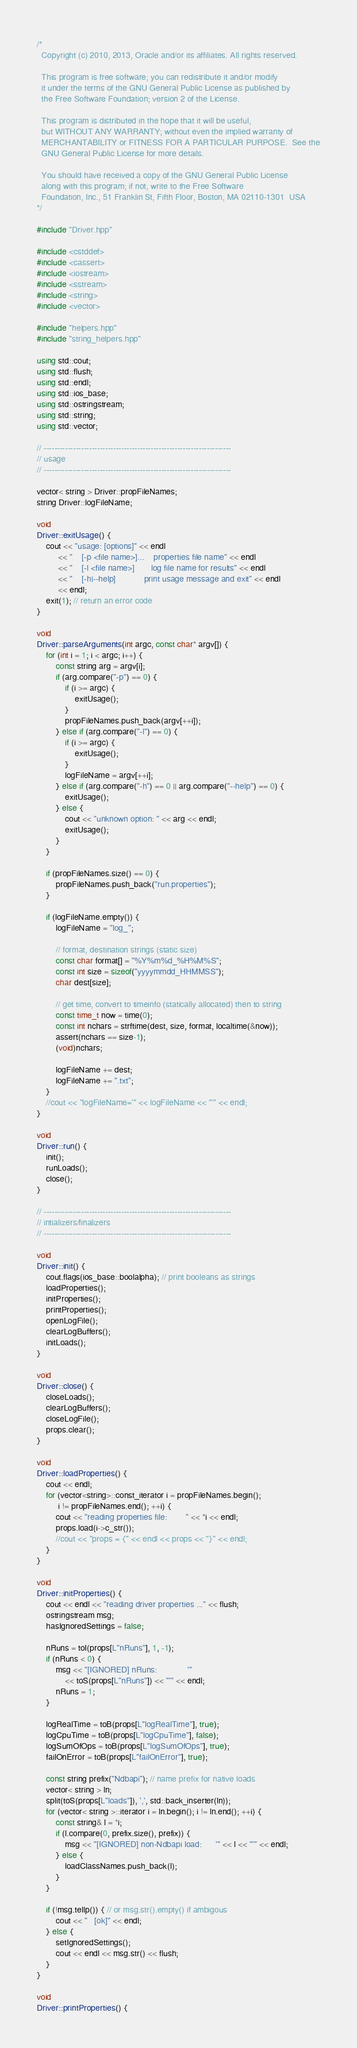Convert code to text. <code><loc_0><loc_0><loc_500><loc_500><_C++_>/*
  Copyright (c) 2010, 2013, Oracle and/or its affiliates. All rights reserved.

  This program is free software; you can redistribute it and/or modify
  it under the terms of the GNU General Public License as published by
  the Free Software Foundation; version 2 of the License.

  This program is distributed in the hope that it will be useful,
  but WITHOUT ANY WARRANTY; without even the implied warranty of
  MERCHANTABILITY or FITNESS FOR A PARTICULAR PURPOSE.  See the
  GNU General Public License for more details.

  You should have received a copy of the GNU General Public License
  along with this program; if not, write to the Free Software
  Foundation, Inc., 51 Franklin St, Fifth Floor, Boston, MA 02110-1301  USA
*/

#include "Driver.hpp"

#include <cstddef>
#include <cassert>
#include <iostream>
#include <sstream>
#include <string>
#include <vector>

#include "helpers.hpp"
#include "string_helpers.hpp"

using std::cout;
using std::flush;
using std::endl;
using std::ios_base;
using std::ostringstream;
using std::string;
using std::vector;

// ----------------------------------------------------------------------
// usage
// ----------------------------------------------------------------------

vector< string > Driver::propFileNames;
string Driver::logFileName;

void
Driver::exitUsage() {
    cout << "usage: [options]" << endl
         << "    [-p <file name>]...    properties file name" << endl
         << "    [-l <file name>]       log file name for results" << endl
         << "    [-h|--help]            print usage message and exit" << endl
         << endl;
    exit(1); // return an error code
}

void
Driver::parseArguments(int argc, const char* argv[]) {
    for (int i = 1; i < argc; i++) {
        const string arg = argv[i];
        if (arg.compare("-p") == 0) {
            if (i >= argc) {
                exitUsage();
            }
            propFileNames.push_back(argv[++i]);
        } else if (arg.compare("-l") == 0) {
            if (i >= argc) {
                exitUsage();
            }
            logFileName = argv[++i];
        } else if (arg.compare("-h") == 0 || arg.compare("--help") == 0) {
            exitUsage();
        } else {
            cout << "unknown option: " << arg << endl;
            exitUsage();
        }
    }

    if (propFileNames.size() == 0) {
        propFileNames.push_back("run.properties");
    }

    if (logFileName.empty()) {
        logFileName = "log_";

        // format, destination strings (static size)
        const char format[] = "%Y%m%d_%H%M%S";
        const int size = sizeof("yyyymmdd_HHMMSS");
        char dest[size];

        // get time, convert to timeinfo (statically allocated) then to string
        const time_t now = time(0);
        const int nchars = strftime(dest, size, format, localtime(&now));
        assert(nchars == size-1);
        (void)nchars;

        logFileName += dest;
        logFileName += ".txt";
    }
    //cout << "logFileName='" << logFileName << "'" << endl;
}

void
Driver::run() {
    init();
    runLoads();
    close();
}

// ----------------------------------------------------------------------
// intializers/finalizers
// ----------------------------------------------------------------------

void
Driver::init() {
    cout.flags(ios_base::boolalpha); // print booleans as strings
    loadProperties();
    initProperties();
    printProperties();
    openLogFile();
    clearLogBuffers();
    initLoads();
}

void
Driver::close() {
    closeLoads();
    clearLogBuffers();
    closeLogFile();
    props.clear();
}

void
Driver::loadProperties() {
    cout << endl;
    for (vector<string>::const_iterator i = propFileNames.begin();
         i != propFileNames.end(); ++i) {
        cout << "reading properties file:        " << *i << endl;
        props.load(i->c_str());
        //cout << "props = {" << endl << props << "}" << endl;
    }
}

void
Driver::initProperties() {
    cout << endl << "reading driver properties ..." << flush;
    ostringstream msg;
    hasIgnoredSettings = false;

    nRuns = toI(props[L"nRuns"], 1, -1);
    if (nRuns < 0) {
        msg << "[IGNORED] nRuns:             '"
            << toS(props[L"nRuns"]) << "'" << endl;
        nRuns = 1;
    }

    logRealTime = toB(props[L"logRealTime"], true);
    logCpuTime = toB(props[L"logCpuTime"], false);
    logSumOfOps = toB(props[L"logSumOfOps"], true);
    failOnError = toB(props[L"failOnError"], true);

    const string prefix("Ndbapi"); // name prefix for native loads
    vector< string > ln;
    split(toS(props[L"loads"]), ',', std::back_inserter(ln));
    for (vector< string >::iterator i = ln.begin(); i != ln.end(); ++i) {
        const string& l = *i;
        if (l.compare(0, prefix.size(), prefix)) {
            msg << "[IGNORED] non-Ndbapi load:      '" << l << "'" << endl;
        } else {
            loadClassNames.push_back(l);
        }
    }

    if (!msg.tellp()) { // or msg.str().empty() if ambigous
        cout << "   [ok]" << endl;
    } else {
        setIgnoredSettings();
        cout << endl << msg.str() << flush;
    }
}

void
Driver::printProperties() {</code> 